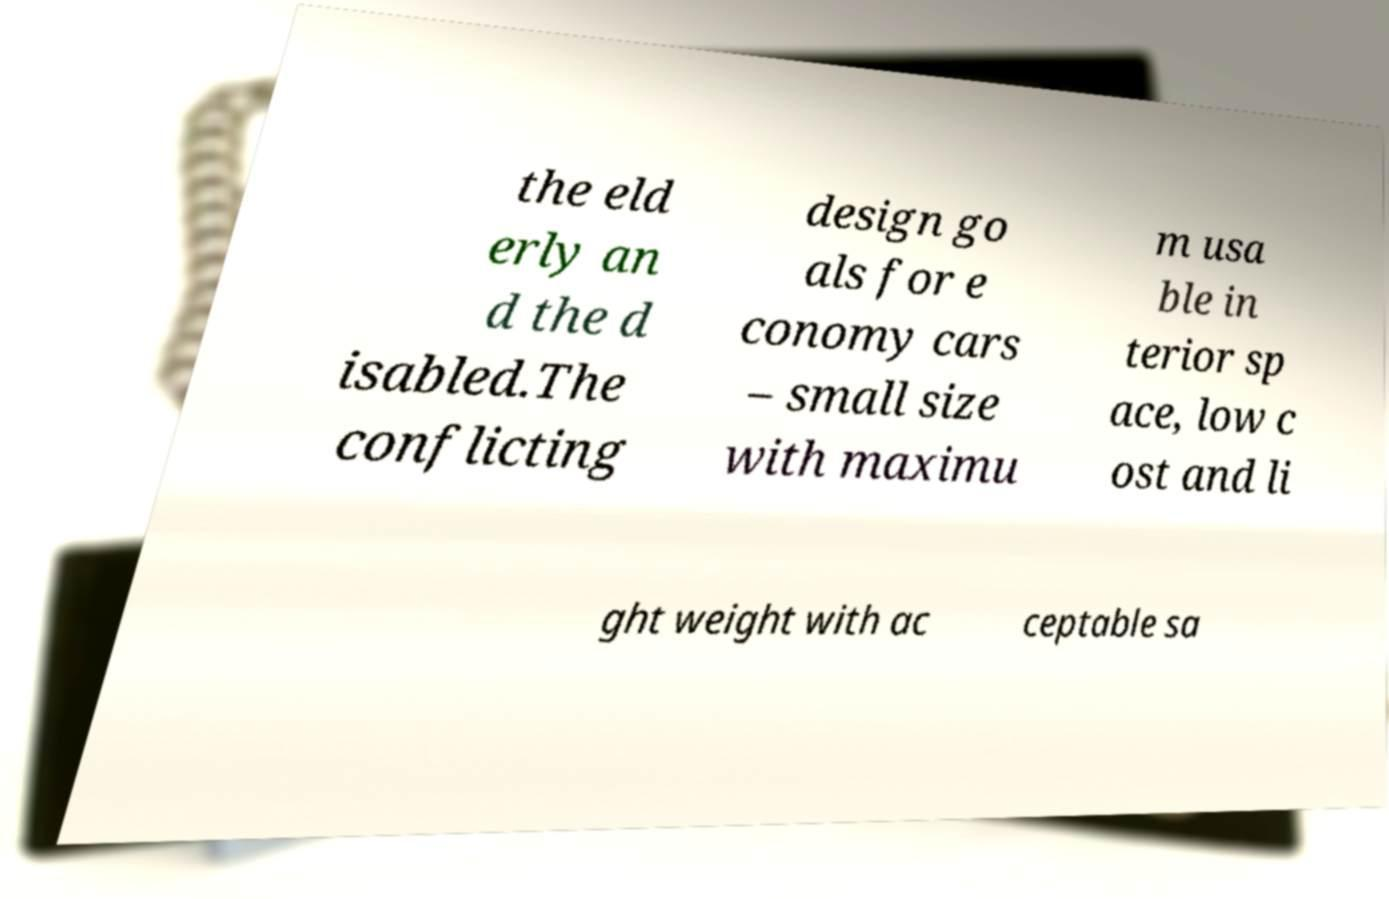Please identify and transcribe the text found in this image. the eld erly an d the d isabled.The conflicting design go als for e conomy cars – small size with maximu m usa ble in terior sp ace, low c ost and li ght weight with ac ceptable sa 